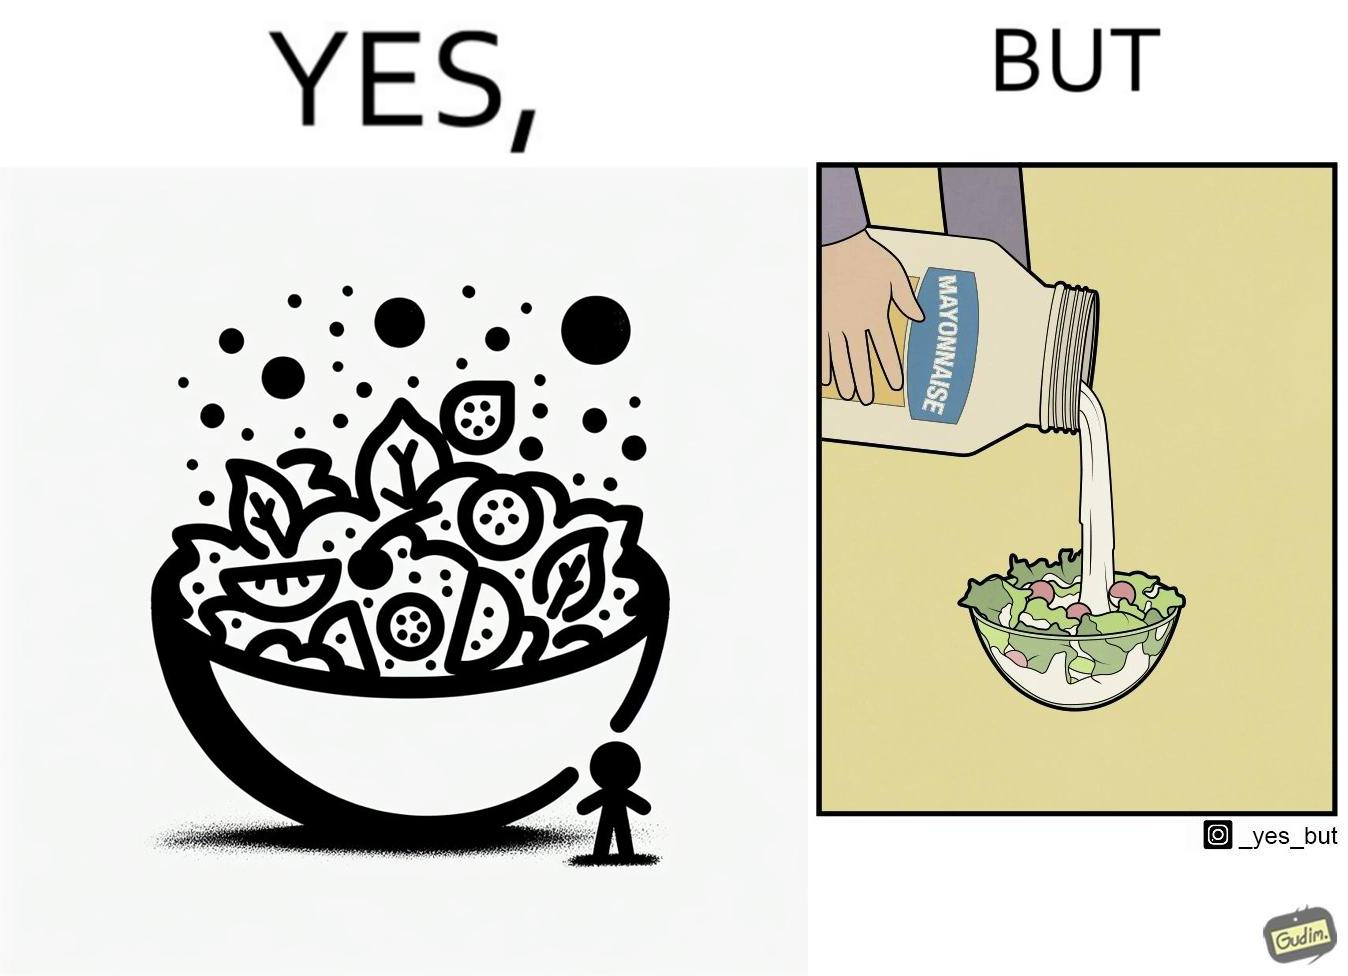Would you classify this image as satirical? Yes, this image is satirical. 